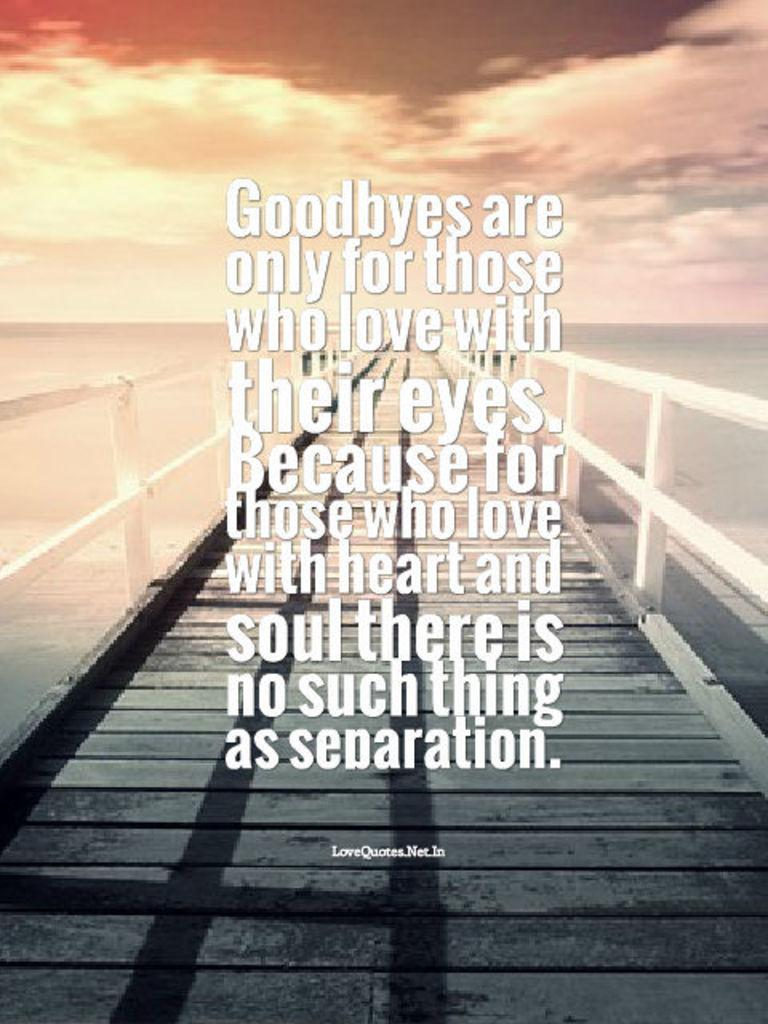<image>
Describe the image concisely. a pier over looking a sunset with words about Goodbyes over it 